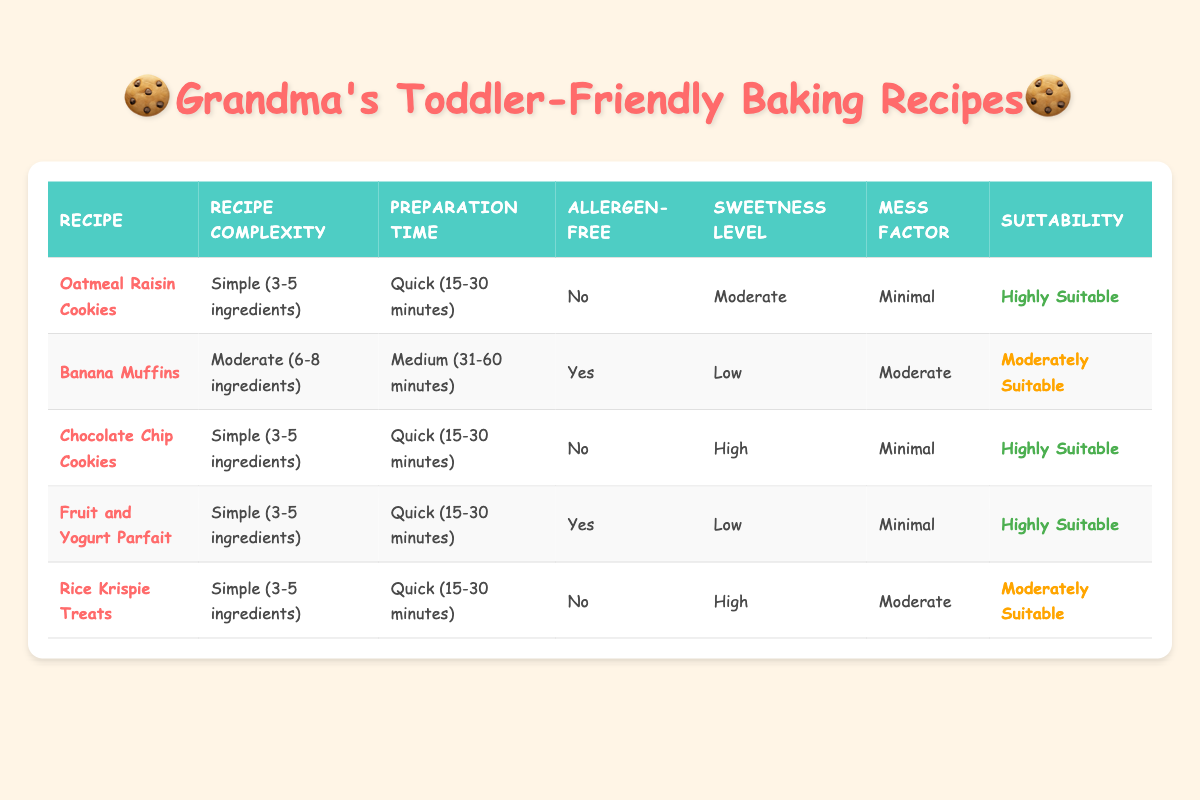What is the simplest recipe based on the number of ingredients? The simplest recipe has 3 to 5 ingredients, which can be found in the “Recipe Complexity” column. The recipes that fall under this category are Oatmeal Raisin Cookies, Chocolate Chip Cookies, Fruit and Yogurt Parfait, and Rice Krispie Treats. Among them, Oatmeal Raisin Cookies is the first one listed in the table.
Answer: Oatmeal Raisin Cookies How many recipes are suitable for toddlers? The suitability of a recipe is categorized in the last column of the table. There are three “Highly Suitable” recipe entries: Oatmeal Raisin Cookies, Chocolate Chip Cookies, and Fruit and Yogurt Parfait. Thus, counting them gives us the total number.
Answer: 3 Is the Banana Muffins recipe allergen-free? We can find the allergen-free status in the “Allergen-Free” column. For Banana Muffins, that column has a value of “Yes.” Therefore, it confirms that the recipe is allergen-free.
Answer: Yes Which recipes have a high sweetness level? The recipes with a "High" sweetness level can be filtered from the “Sweetness Level” column. The recipes that fit this criterion are Chocolate Chip Cookies and Rice Krispie Treats. Thus, we look for the corresponding rows to identify these recipes.
Answer: Chocolate Chip Cookies, Rice Krispie Treats How many recipes are both simple and suitable for toddlers? The keyword “simple” corresponds to recipes with 3 to 5 ingredients, and we check for the suitability category in the last column. The recipes tagged as “Highly Suitable” that are also “Simple” are Oatmeal Raisin Cookies, Chocolate Chip Cookies, and Fruit and Yogurt Parfait. Counting these, we get the number of recipes fulfilling both criteria.
Answer: 3 What is the difference in preparation time between the simplest and the most complex recipe? To determine the difference, we compare the preparation times. The simplest recipes (Oatmeal Raisin Cookies and others) can be prepared in "Quick (15-30 minutes)," whereas the most complex recipe requires "Long (60+ minutes)." The difference in time is calculated as follows: 60+ minutes minus 15 minutes (taking the lower end of the quick time range) equals 45 minutes.
Answer: 45 minutes Are there more recipes with a moderate or a high mess factor? In the “Mess Factor” column, we can see the following: "Minimal" appears 4 times (Oatmeal Raisin Cookies, Chocolate Chip Cookies, and others), "Moderate" appears 3 times, and "High" appears once. Thus, we can conclude that there are more recipes with a moderate mess factor than with a high one.
Answer: More moderate Which recipe has the shortest preparation time? The preparation time can be found in the second column. The shortest preparation time is “Quick (15-30 minutes),” and all recipes listed under this preparation time are Oatmeal Raisin Cookies, Chocolate Chip Cookies, and Fruit and Yogurt Parfait. The first one listed in the table corresponds to the minimum time.
Answer: Oatmeal Raisin Cookies How many recipes are considered “Not Suitable”? Looking at the last column, "Not Suitable" only appears for one recipe, which is the Complex recipe requiring "Long (60+ minutes)" preparation time. This confirms the total count for the "Not Suitable" category.
Answer: 1 